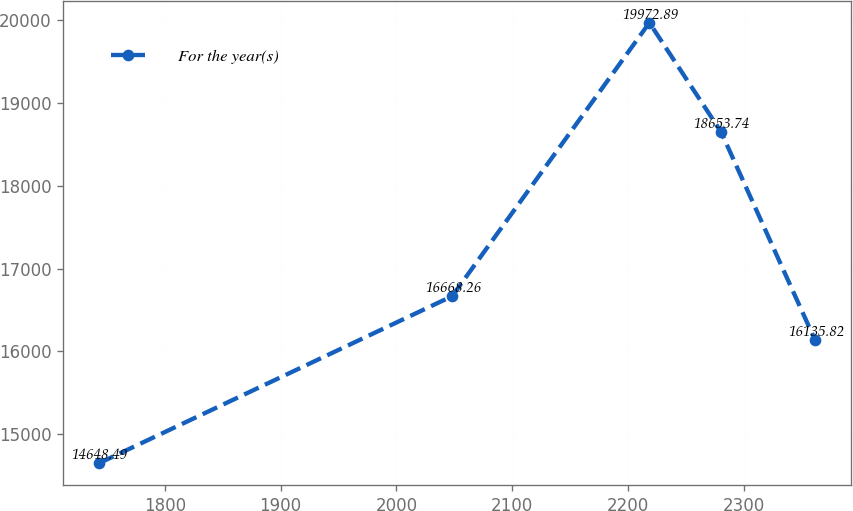<chart> <loc_0><loc_0><loc_500><loc_500><line_chart><ecel><fcel>For the year(s)<nl><fcel>1742.98<fcel>14648.5<nl><fcel>2048.09<fcel>16668.3<nl><fcel>2218.42<fcel>19972.9<nl><fcel>2280.28<fcel>18653.7<nl><fcel>2361.54<fcel>16135.8<nl></chart> 